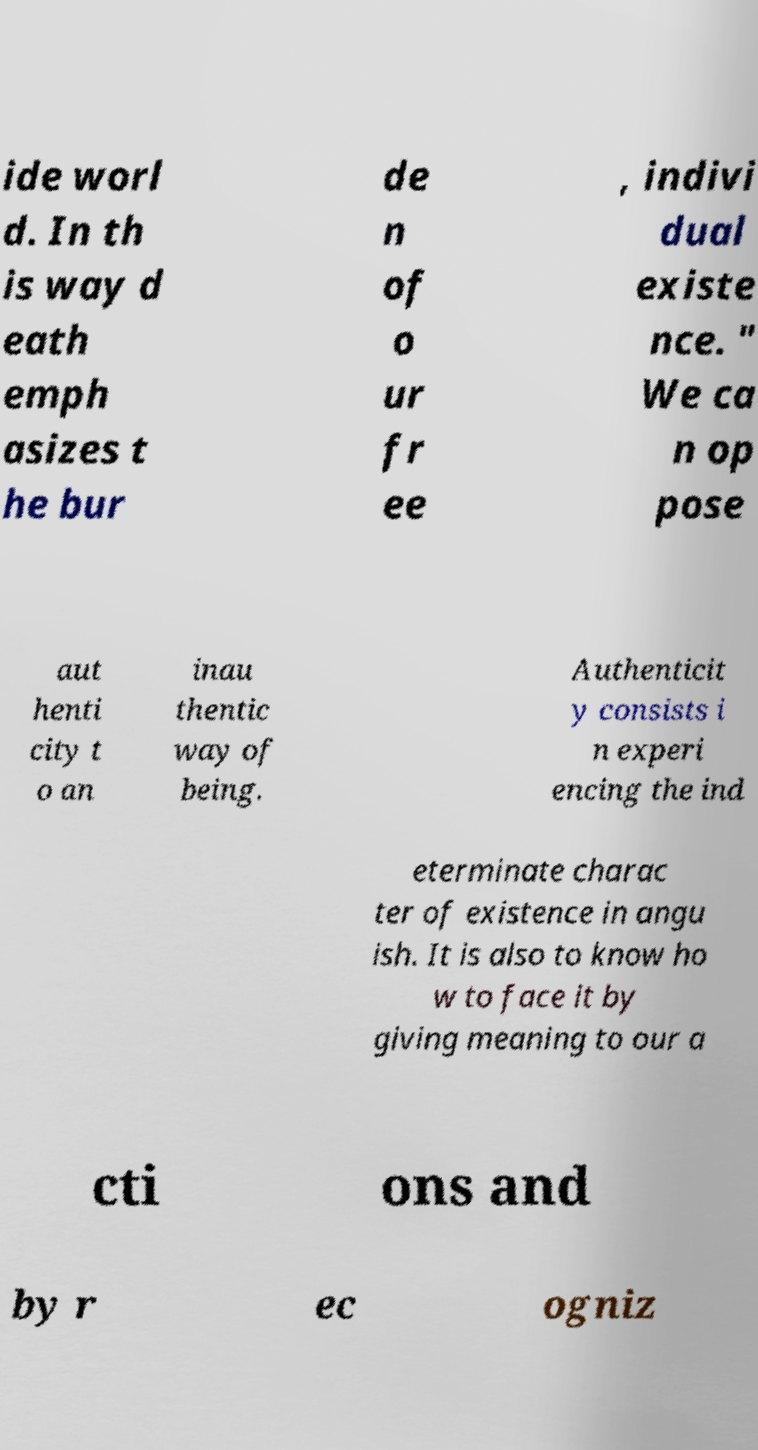Can you read and provide the text displayed in the image?This photo seems to have some interesting text. Can you extract and type it out for me? ide worl d. In th is way d eath emph asizes t he bur de n of o ur fr ee , indivi dual existe nce. " We ca n op pose aut henti city t o an inau thentic way of being. Authenticit y consists i n experi encing the ind eterminate charac ter of existence in angu ish. It is also to know ho w to face it by giving meaning to our a cti ons and by r ec ogniz 